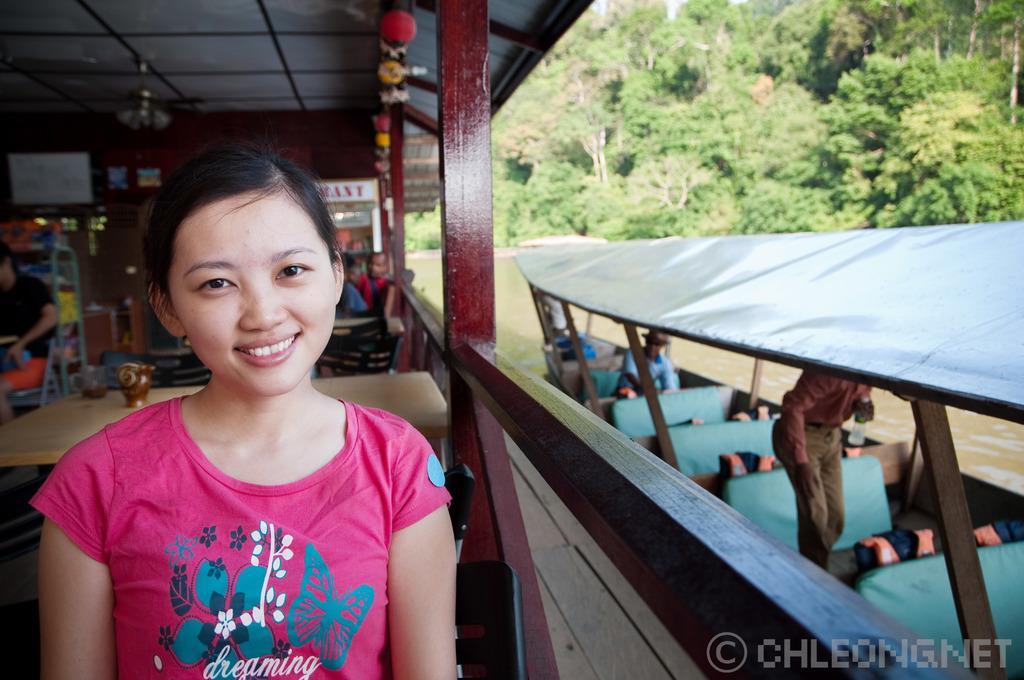Describe this image in one or two sentences. This picture shows a group of people seated on the chairs and we see a woman seated and we see a boat on the side and we see trees and water 